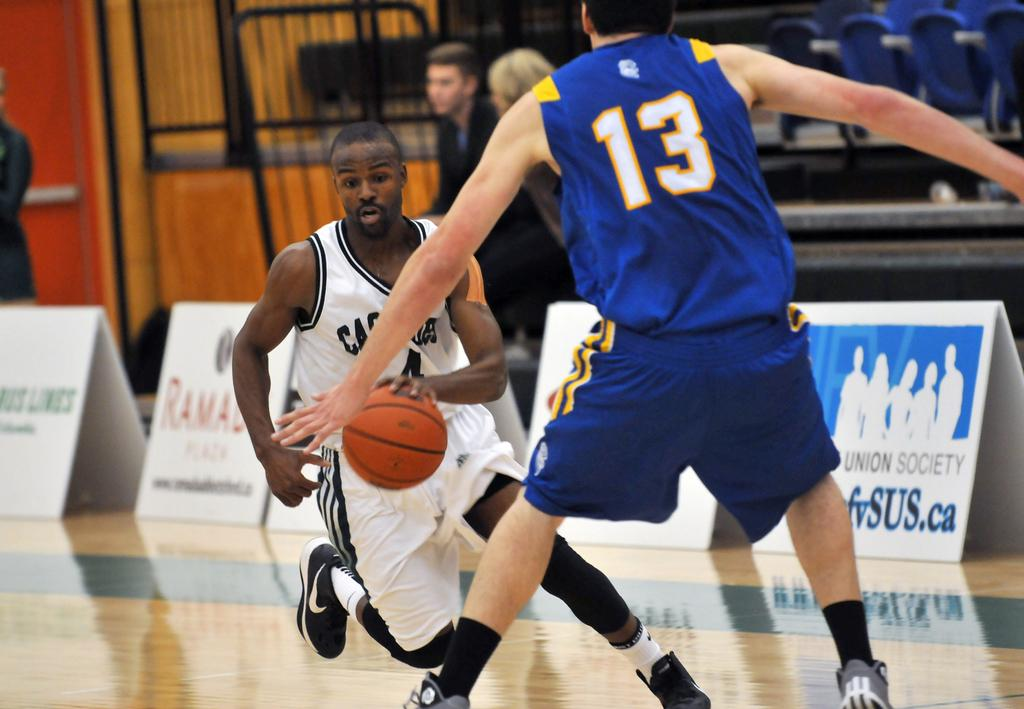<image>
Offer a succinct explanation of the picture presented. On the player blue jersey is the number 13. 